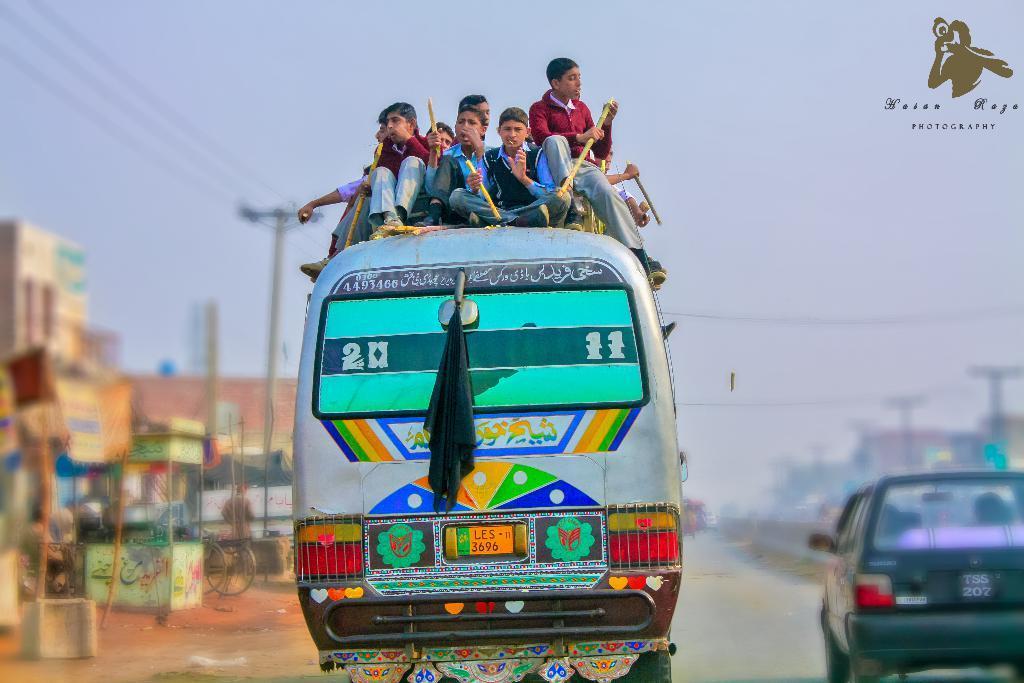Could you give a brief overview of what you see in this image? In the image in the center,we can see one bus on the road. On the bus,we can see few people were sitting and holding some objects. In the background we can see the sky,buildings,vehicles,poles,banners etc. 